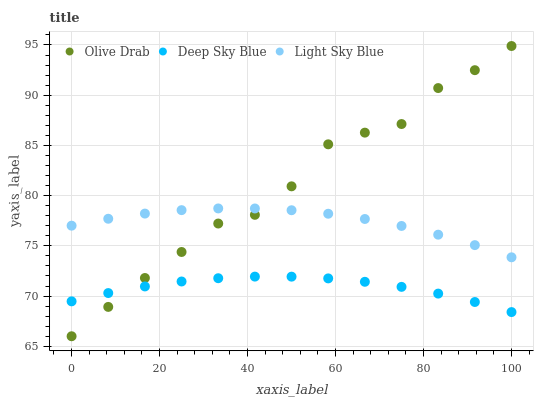Does Deep Sky Blue have the minimum area under the curve?
Answer yes or no. Yes. Does Olive Drab have the maximum area under the curve?
Answer yes or no. Yes. Does Olive Drab have the minimum area under the curve?
Answer yes or no. No. Does Deep Sky Blue have the maximum area under the curve?
Answer yes or no. No. Is Deep Sky Blue the smoothest?
Answer yes or no. Yes. Is Olive Drab the roughest?
Answer yes or no. Yes. Is Olive Drab the smoothest?
Answer yes or no. No. Is Deep Sky Blue the roughest?
Answer yes or no. No. Does Olive Drab have the lowest value?
Answer yes or no. Yes. Does Deep Sky Blue have the lowest value?
Answer yes or no. No. Does Olive Drab have the highest value?
Answer yes or no. Yes. Does Deep Sky Blue have the highest value?
Answer yes or no. No. Is Deep Sky Blue less than Light Sky Blue?
Answer yes or no. Yes. Is Light Sky Blue greater than Deep Sky Blue?
Answer yes or no. Yes. Does Olive Drab intersect Deep Sky Blue?
Answer yes or no. Yes. Is Olive Drab less than Deep Sky Blue?
Answer yes or no. No. Is Olive Drab greater than Deep Sky Blue?
Answer yes or no. No. Does Deep Sky Blue intersect Light Sky Blue?
Answer yes or no. No. 